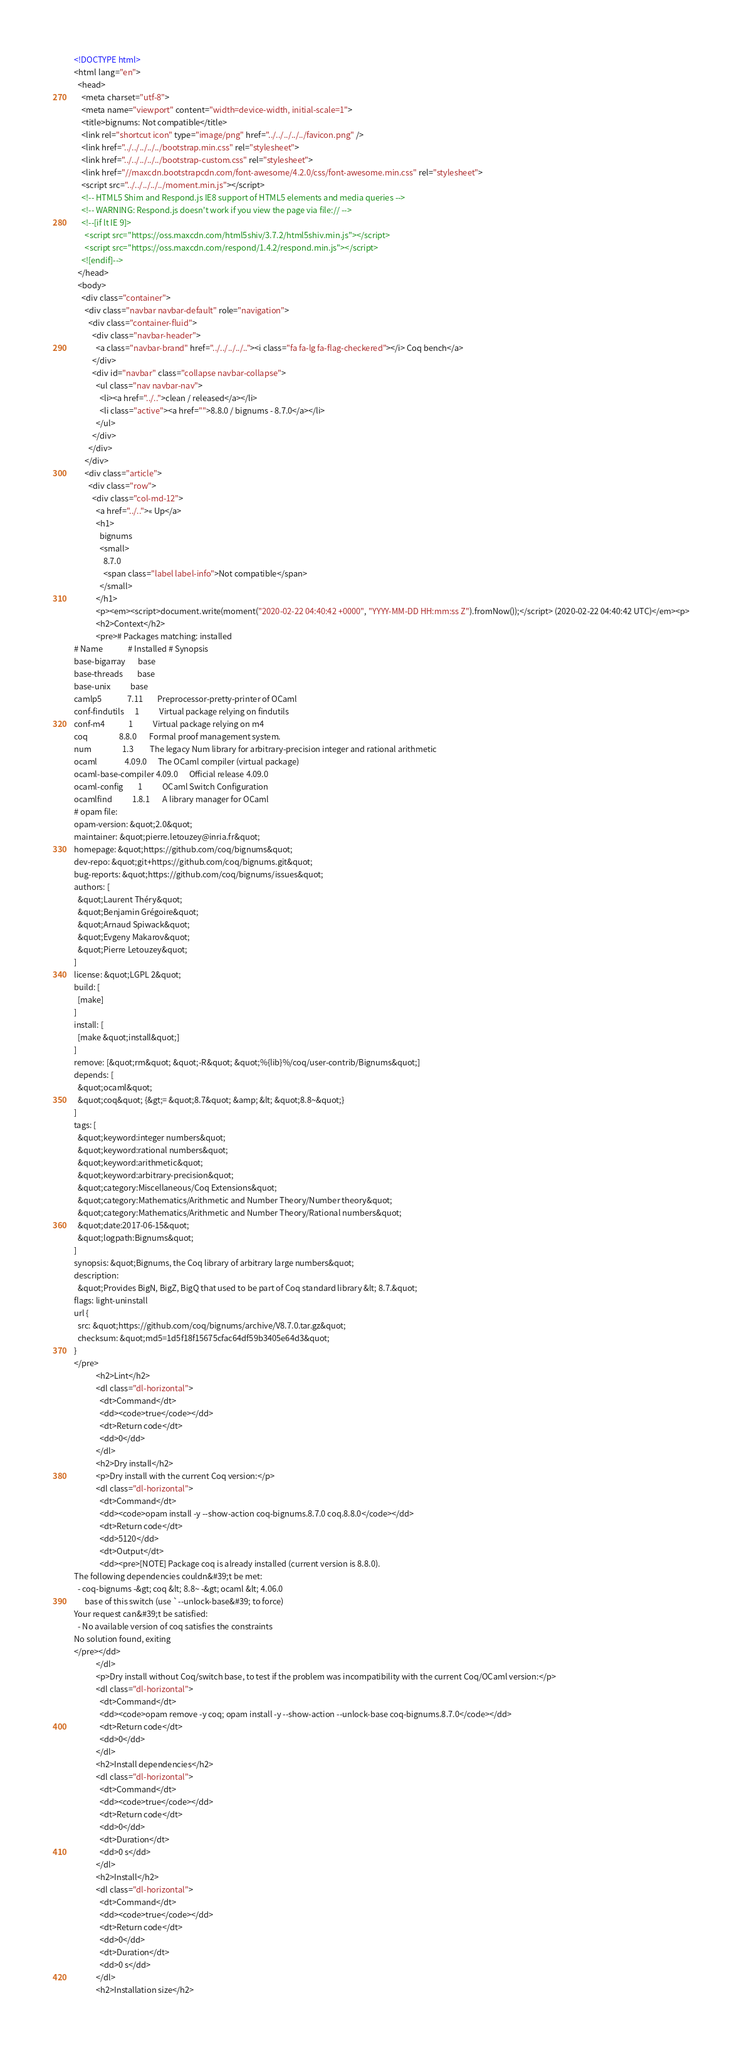<code> <loc_0><loc_0><loc_500><loc_500><_HTML_><!DOCTYPE html>
<html lang="en">
  <head>
    <meta charset="utf-8">
    <meta name="viewport" content="width=device-width, initial-scale=1">
    <title>bignums: Not compatible</title>
    <link rel="shortcut icon" type="image/png" href="../../../../../favicon.png" />
    <link href="../../../../../bootstrap.min.css" rel="stylesheet">
    <link href="../../../../../bootstrap-custom.css" rel="stylesheet">
    <link href="//maxcdn.bootstrapcdn.com/font-awesome/4.2.0/css/font-awesome.min.css" rel="stylesheet">
    <script src="../../../../../moment.min.js"></script>
    <!-- HTML5 Shim and Respond.js IE8 support of HTML5 elements and media queries -->
    <!-- WARNING: Respond.js doesn't work if you view the page via file:// -->
    <!--[if lt IE 9]>
      <script src="https://oss.maxcdn.com/html5shiv/3.7.2/html5shiv.min.js"></script>
      <script src="https://oss.maxcdn.com/respond/1.4.2/respond.min.js"></script>
    <![endif]-->
  </head>
  <body>
    <div class="container">
      <div class="navbar navbar-default" role="navigation">
        <div class="container-fluid">
          <div class="navbar-header">
            <a class="navbar-brand" href="../../../../.."><i class="fa fa-lg fa-flag-checkered"></i> Coq bench</a>
          </div>
          <div id="navbar" class="collapse navbar-collapse">
            <ul class="nav navbar-nav">
              <li><a href="../..">clean / released</a></li>
              <li class="active"><a href="">8.8.0 / bignums - 8.7.0</a></li>
            </ul>
          </div>
        </div>
      </div>
      <div class="article">
        <div class="row">
          <div class="col-md-12">
            <a href="../..">« Up</a>
            <h1>
              bignums
              <small>
                8.7.0
                <span class="label label-info">Not compatible</span>
              </small>
            </h1>
            <p><em><script>document.write(moment("2020-02-22 04:40:42 +0000", "YYYY-MM-DD HH:mm:ss Z").fromNow());</script> (2020-02-22 04:40:42 UTC)</em><p>
            <h2>Context</h2>
            <pre># Packages matching: installed
# Name              # Installed # Synopsis
base-bigarray       base
base-threads        base
base-unix           base
camlp5              7.11        Preprocessor-pretty-printer of OCaml
conf-findutils      1           Virtual package relying on findutils
conf-m4             1           Virtual package relying on m4
coq                 8.8.0       Formal proof management system.
num                 1.3         The legacy Num library for arbitrary-precision integer and rational arithmetic
ocaml               4.09.0      The OCaml compiler (virtual package)
ocaml-base-compiler 4.09.0      Official release 4.09.0
ocaml-config        1           OCaml Switch Configuration
ocamlfind           1.8.1       A library manager for OCaml
# opam file:
opam-version: &quot;2.0&quot;
maintainer: &quot;pierre.letouzey@inria.fr&quot;
homepage: &quot;https://github.com/coq/bignums&quot;
dev-repo: &quot;git+https://github.com/coq/bignums.git&quot;
bug-reports: &quot;https://github.com/coq/bignums/issues&quot;
authors: [
  &quot;Laurent Théry&quot;
  &quot;Benjamin Grégoire&quot;
  &quot;Arnaud Spiwack&quot;
  &quot;Evgeny Makarov&quot;
  &quot;Pierre Letouzey&quot;
]
license: &quot;LGPL 2&quot;
build: [
  [make]
]
install: [
  [make &quot;install&quot;]
]
remove: [&quot;rm&quot; &quot;-R&quot; &quot;%{lib}%/coq/user-contrib/Bignums&quot;]
depends: [
  &quot;ocaml&quot;
  &quot;coq&quot; {&gt;= &quot;8.7&quot; &amp; &lt; &quot;8.8~&quot;}
]
tags: [
  &quot;keyword:integer numbers&quot;
  &quot;keyword:rational numbers&quot;
  &quot;keyword:arithmetic&quot;
  &quot;keyword:arbitrary-precision&quot;
  &quot;category:Miscellaneous/Coq Extensions&quot;
  &quot;category:Mathematics/Arithmetic and Number Theory/Number theory&quot;
  &quot;category:Mathematics/Arithmetic and Number Theory/Rational numbers&quot;
  &quot;date:2017-06-15&quot;
  &quot;logpath:Bignums&quot;
]
synopsis: &quot;Bignums, the Coq library of arbitrary large numbers&quot;
description:
  &quot;Provides BigN, BigZ, BigQ that used to be part of Coq standard library &lt; 8.7.&quot;
flags: light-uninstall
url {
  src: &quot;https://github.com/coq/bignums/archive/V8.7.0.tar.gz&quot;
  checksum: &quot;md5=1d5f18f15675cfac64df59b3405e64d3&quot;
}
</pre>
            <h2>Lint</h2>
            <dl class="dl-horizontal">
              <dt>Command</dt>
              <dd><code>true</code></dd>
              <dt>Return code</dt>
              <dd>0</dd>
            </dl>
            <h2>Dry install</h2>
            <p>Dry install with the current Coq version:</p>
            <dl class="dl-horizontal">
              <dt>Command</dt>
              <dd><code>opam install -y --show-action coq-bignums.8.7.0 coq.8.8.0</code></dd>
              <dt>Return code</dt>
              <dd>5120</dd>
              <dt>Output</dt>
              <dd><pre>[NOTE] Package coq is already installed (current version is 8.8.0).
The following dependencies couldn&#39;t be met:
  - coq-bignums -&gt; coq &lt; 8.8~ -&gt; ocaml &lt; 4.06.0
      base of this switch (use `--unlock-base&#39; to force)
Your request can&#39;t be satisfied:
  - No available version of coq satisfies the constraints
No solution found, exiting
</pre></dd>
            </dl>
            <p>Dry install without Coq/switch base, to test if the problem was incompatibility with the current Coq/OCaml version:</p>
            <dl class="dl-horizontal">
              <dt>Command</dt>
              <dd><code>opam remove -y coq; opam install -y --show-action --unlock-base coq-bignums.8.7.0</code></dd>
              <dt>Return code</dt>
              <dd>0</dd>
            </dl>
            <h2>Install dependencies</h2>
            <dl class="dl-horizontal">
              <dt>Command</dt>
              <dd><code>true</code></dd>
              <dt>Return code</dt>
              <dd>0</dd>
              <dt>Duration</dt>
              <dd>0 s</dd>
            </dl>
            <h2>Install</h2>
            <dl class="dl-horizontal">
              <dt>Command</dt>
              <dd><code>true</code></dd>
              <dt>Return code</dt>
              <dd>0</dd>
              <dt>Duration</dt>
              <dd>0 s</dd>
            </dl>
            <h2>Installation size</h2></code> 